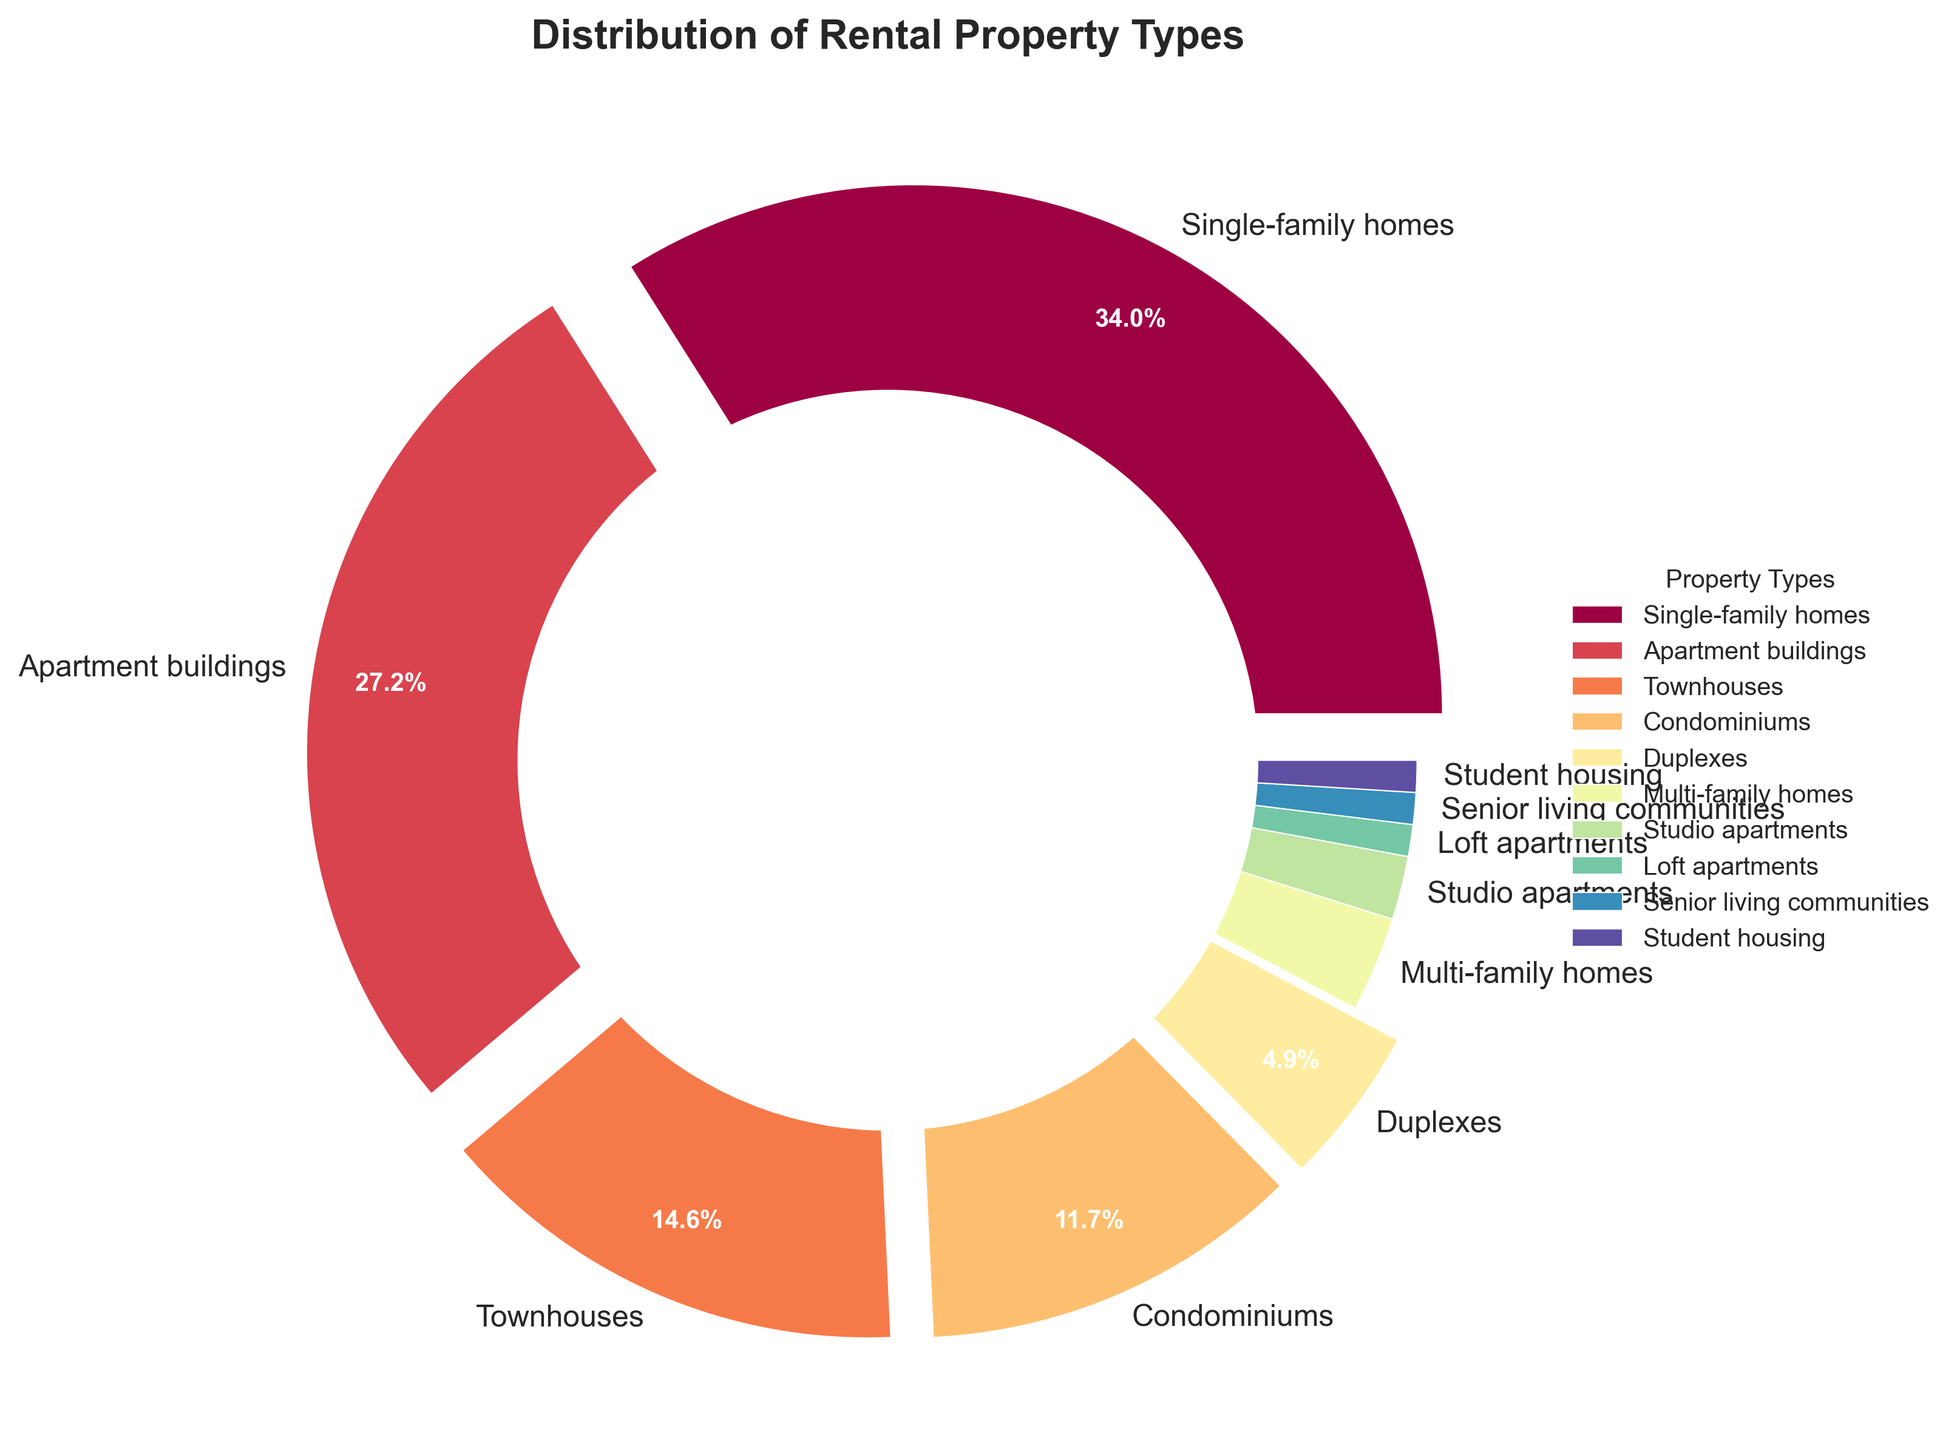What's the most common property type in the city? The most common property type is the one with the largest pie slice. Single-family homes are the largest slice at 35%.
Answer: Single-family homes Which property type has nearly half the percentage of Apartment buildings? Apartment buildings have 28%. Half of 28% is 14%. The closest property type is Townhouses with 15%.
Answer: Townhouses What proportion of the total do Duplexes and Multi-family homes together represent? Duplexes represent 5% and Multi-family homes represent 3%. Adding these together: 5% + 3% = 8%
Answer: 8% How does the combined percentage of Condominiums and Townhouses compare to Single-family homes? Condominiums have 12% and Townhouses have 15%. Adding them: 12% + 15% = 27%. Single-family homes have 35%. 27% is less than 35%.
Answer: Less than What percentage of the total is comprised of property types with less than or equal to 3% each? Adding the percentages of Multi-family homes (3%), Studio apartments (2%), Loft apartments (1%), Senior living communities (1%), and Student housing (1%): 3% + 2% + 1% + 1% + 1% = 8%
Answer: 8% Which slice has the smallest representation in the pie chart and what is its percentage? The smallest slice is Loft apartments, Senior living communities, and Student housing. Each represents 1%.
Answer: 1% Is the segment for Condominiums visually exploded from the center, and why? Condominiums have 12%, which is greater than 3%, so it is visually exploded from the center.
Answer: Yes How many property types together make up more than half of the pie chart? Single-family homes (35%) and Apartment buildings (28%) together make up 35% + 28% = 63%, which is more than half.
Answer: 2 What property type represents the middle percentage among Townhouses, Condominiums, and Duplexes? Among these, Townhouses (15%), Condominiums (12%), and Duplexes (5%), the middle value is 12%, which is Condominiums.
Answer: Condominiums Which property type has a percentage closest to the combined percentage of Loft apartments and Senior living communities? Loft apartments (1%) and Senior living communities (1%) together make up 2%. Studio apartments also have a percentage of 2%, which is the closest.
Answer: Studio apartments 